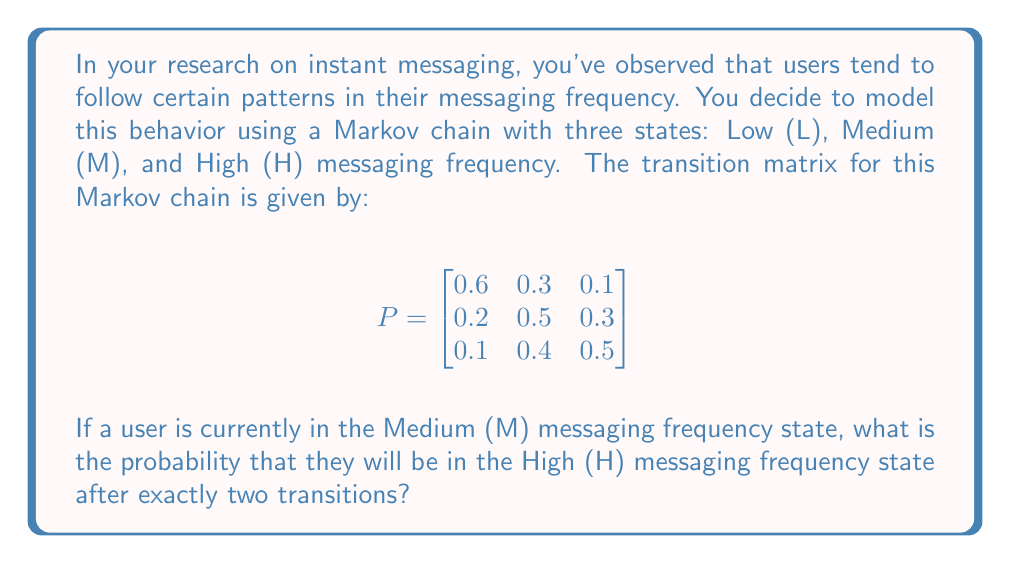What is the answer to this math problem? To solve this problem, we need to use the properties of Markov chains and matrix multiplication. Let's break it down step-by-step:

1) The initial state vector for a user in the Medium (M) state is:
   $$v_0 = \begin{bmatrix} 0 & 1 & 0 \end{bmatrix}$$

2) To find the probability distribution after two transitions, we need to multiply the initial state vector by the transition matrix twice:
   $$v_2 = v_0 \cdot P^2$$

3) First, let's calculate $P^2$:
   $$P^2 = P \cdot P = \begin{bmatrix}
   0.6 & 0.3 & 0.1 \\
   0.2 & 0.5 & 0.3 \\
   0.1 & 0.4 & 0.5
   \end{bmatrix} \cdot \begin{bmatrix}
   0.6 & 0.3 & 0.1 \\
   0.2 & 0.5 & 0.3 \\
   0.1 & 0.4 & 0.5
   \end{bmatrix}$$

4) Performing the matrix multiplication:
   $$P^2 = \begin{bmatrix}
   0.41 & 0.39 & 0.20 \\
   0.23 & 0.46 & 0.31 \\
   0.19 & 0.44 & 0.37
   \end{bmatrix}$$

5) Now, we multiply $v_0$ by $P^2$:
   $$v_2 = \begin{bmatrix} 0 & 1 & 0 \end{bmatrix} \cdot \begin{bmatrix}
   0.41 & 0.39 & 0.20 \\
   0.23 & 0.46 & 0.31 \\
   0.19 & 0.44 & 0.37
   \end{bmatrix}$$

6) This multiplication gives us:
   $$v_2 = \begin{bmatrix} 0.23 & 0.46 & 0.31 \end{bmatrix}$$

7) The probability of being in the High (H) state after two transitions is the third element of this vector: 0.31 or 31%.
Answer: 0.31 